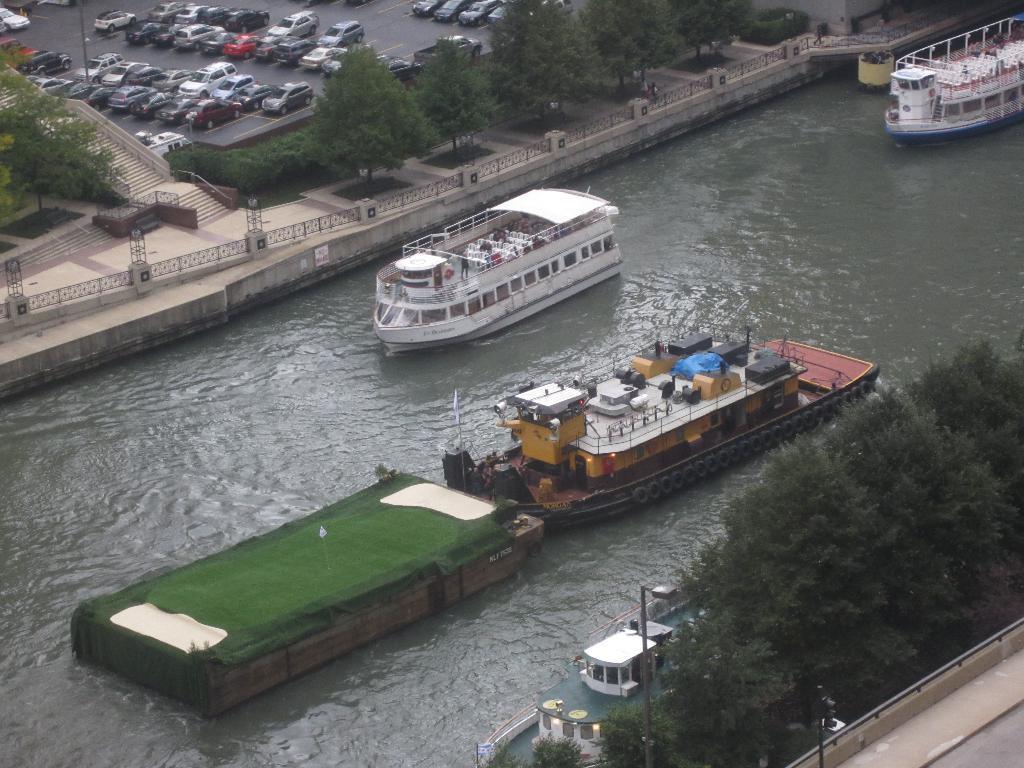Please provide a concise description of this image. In this picture we can see boats on water and in the background we can see trees,vehicles on the ground. 